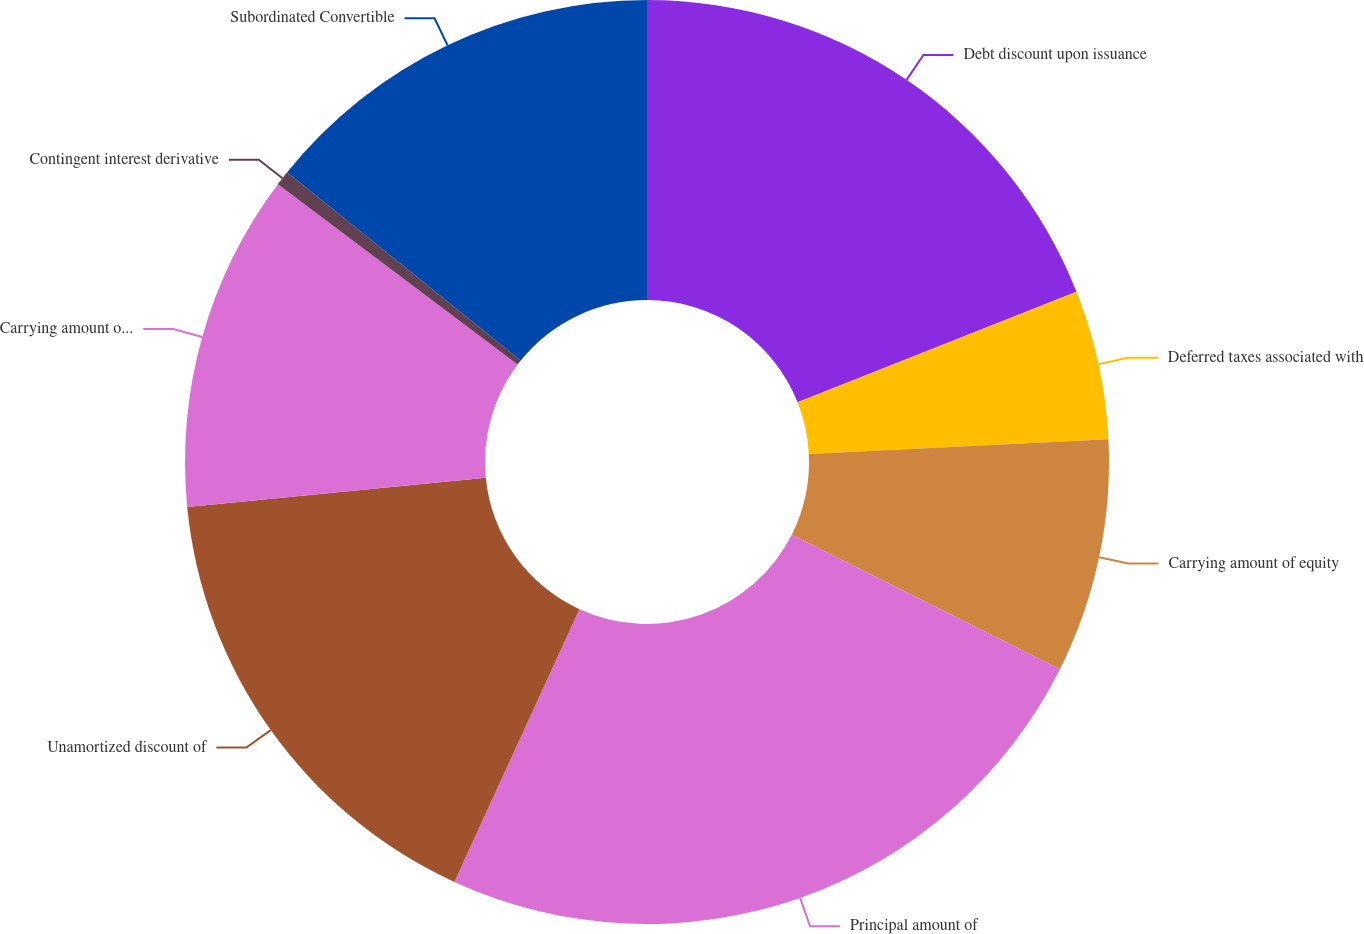Convert chart. <chart><loc_0><loc_0><loc_500><loc_500><pie_chart><fcel>Debt discount upon issuance<fcel>Deferred taxes associated with<fcel>Carrying amount of equity<fcel>Principal amount of<fcel>Unamortized discount of<fcel>Carrying amount of liability<fcel>Contingent interest derivative<fcel>Subordinated Convertible<nl><fcel>18.99%<fcel>5.22%<fcel>8.19%<fcel>24.44%<fcel>16.6%<fcel>11.82%<fcel>0.52%<fcel>14.21%<nl></chart> 